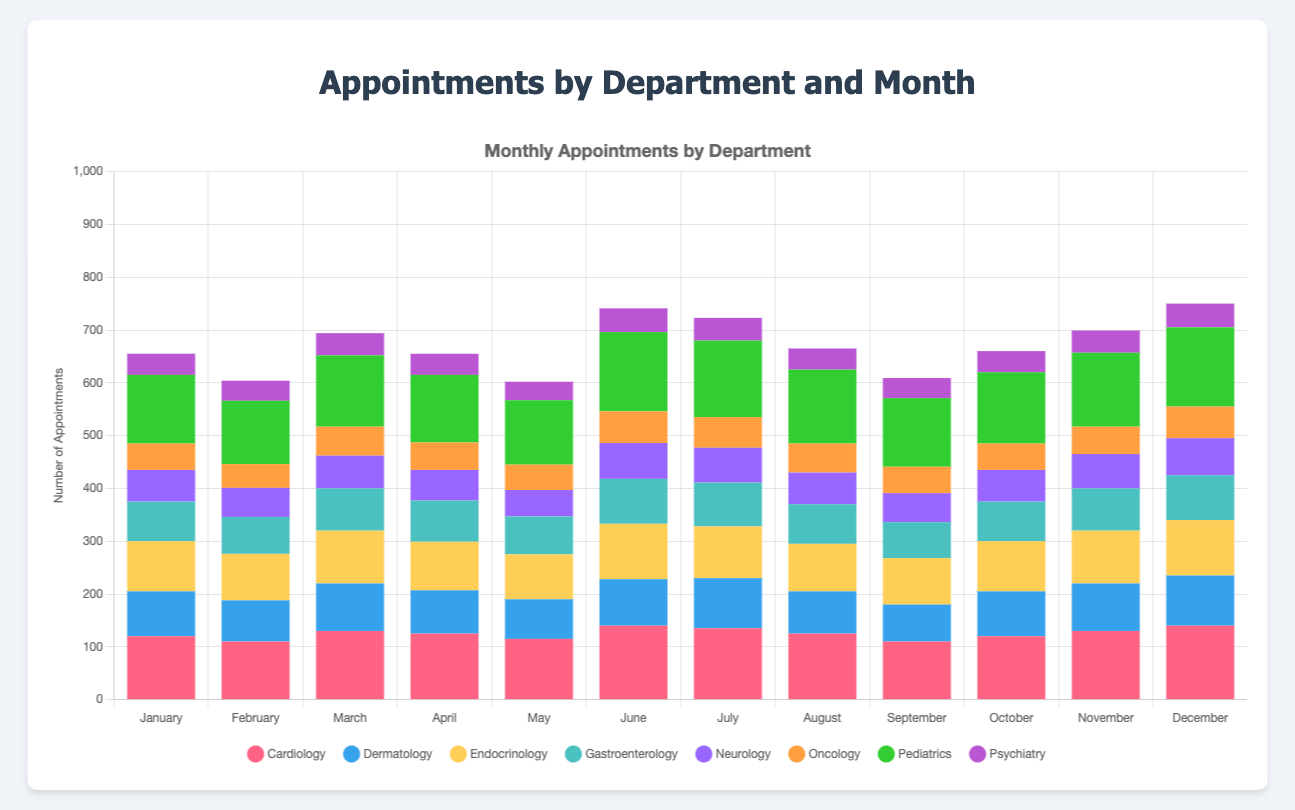How many total appointments were there in January? Sum the appointments for all departments in January: 120 (Cardiology) + 85 (Dermatology) + 95 (Endocrinology) + 75 (Gastroenterology) + 60 (Neurology) + 50 (Oncology) + 130 (Pediatrics) + 40 (Psychiatry) = 655
Answer: 655 Which department had the highest number of appointments in June? Look at June's data and compare the values. Cardiology has 140, Dermatology has 88, Endocrinology has 105, Gastroenterology has 85, Neurology has 68, Oncology has 60, Pediatrics has 150, and Psychiatry has 45. Pediatrics has the highest number.
Answer: Pediatrics In which month did Cardiology have the lowest number of appointments? Compare the Cardiology values across all months: January (120), February (110), March (130), April (125), May (115), June (140), July (135), August (125), September (110), October (120), November (130), December (140). February and September both have the lowest value at 110.
Answer: February and September What is the difference in the number of Oncology appointments between May and December? Subtract the number of Oncology appointments in May (48) from the number in December (60): 60 - 48 = 12
Answer: 12 Which department had the most consistent number of appointments each month? To determine consistency, check the variability of the numbers. Psychiatry numbers are: 40, 38, 42, 40, 35, 45, 43, 40, 38, 40, 42, 45. These values are close to each other, indicating Psychiatry is the most consistent.
Answer: Psychiatry Comparing August and October, which department had the greatest increase or decrease in appointments? Calculate the difference for each department between August and October. Cardiology (125 to 120: -5), Dermatology (80 to 85: +5), Endocrinology (90 to 95: +5), Gastroenterology (75 to 75: 0), Neurology (60 to 60: 0), Oncology (55 to 50: -5), Pediatrics (140 to 135: -5), Psychiatry (40 to 40: 0). The greatest change is in Pediatrics, Dermatology, and Endocrinology (each -5 or +5).
Answer: Pediatrics, Dermatology, Endocrinology What is the average number of appointments for Neurology across the entire year? Sum the number of Neurology appointments over 12 months and divide by 12: (60 + 55 + 62 + 58 + 50 + 68 + 66 + 60 + 55 + 60 + 65 + 70) = 729, and 729 / 12 ≈ 60.75
Answer: 60.75 Which two consecutive months show the highest increase in total appointments for Gastroenterology? Calculate the differences in Gastroenterology appointments between consecutive months: January to February (75 to 70: -5), February to March (70 to 80: +10), March to April (80 to 78: -2), April to May (78 to 72: -6), May to June (72 to 85: +13), June to July (85 to 83: -2), July to August (83 to 75: -8), August to September (75 to 68: -7), September to October (68 to 75: +7), October to November (75 to 80: +5), November to December (80 to 85: +5). The highest increase is from May to June (+13).
Answer: May to June 